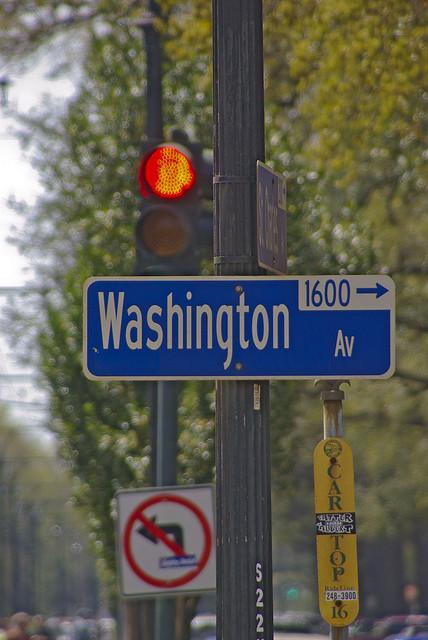What color is the light?
Answer briefly. Red. Where is the White House?
Concise answer only. Right. What is the street showing on the sign?
Give a very brief answer. Washington av. Is the street name the name of a famous person?
Quick response, please. Yes. Is the sign for a street or Avenue?
Short answer required. Avenue. 